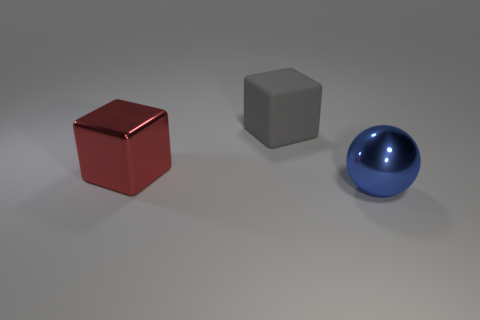What color is the rubber block that is the same size as the blue thing?
Make the answer very short. Gray. Do the big object to the right of the big gray rubber thing and the big metallic thing that is to the left of the blue thing have the same color?
Offer a terse response. No. There is a blue object that is in front of the large red shiny block; what is it made of?
Provide a succinct answer. Metal. What color is the block that is the same material as the blue thing?
Make the answer very short. Red. What number of other things are the same size as the red metallic thing?
Provide a short and direct response. 2. There is a metallic object that is on the left side of the metallic sphere; is it the same size as the large gray matte thing?
Ensure brevity in your answer.  Yes. There is a thing that is both to the right of the large red metallic block and in front of the gray rubber cube; what shape is it?
Provide a short and direct response. Sphere. There is a big rubber block; are there any big metal objects in front of it?
Your answer should be very brief. Yes. Is there anything else that is the same shape as the blue object?
Your response must be concise. No. Is the big red metal object the same shape as the blue thing?
Provide a succinct answer. No. 